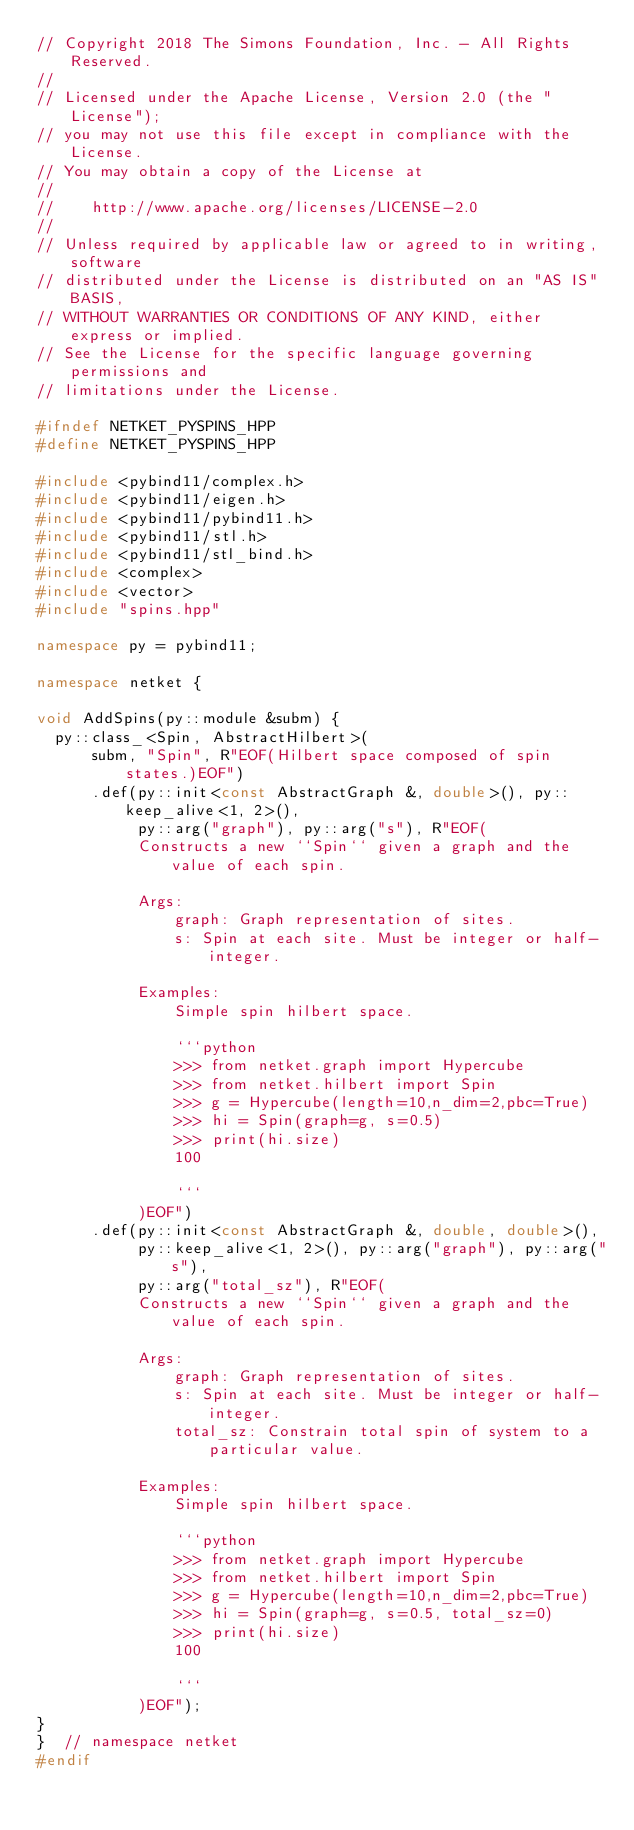<code> <loc_0><loc_0><loc_500><loc_500><_C++_>// Copyright 2018 The Simons Foundation, Inc. - All Rights Reserved.
//
// Licensed under the Apache License, Version 2.0 (the "License");
// you may not use this file except in compliance with the License.
// You may obtain a copy of the License at
//
//    http://www.apache.org/licenses/LICENSE-2.0
//
// Unless required by applicable law or agreed to in writing, software
// distributed under the License is distributed on an "AS IS" BASIS,
// WITHOUT WARRANTIES OR CONDITIONS OF ANY KIND, either express or implied.
// See the License for the specific language governing permissions and
// limitations under the License.

#ifndef NETKET_PYSPINS_HPP
#define NETKET_PYSPINS_HPP

#include <pybind11/complex.h>
#include <pybind11/eigen.h>
#include <pybind11/pybind11.h>
#include <pybind11/stl.h>
#include <pybind11/stl_bind.h>
#include <complex>
#include <vector>
#include "spins.hpp"

namespace py = pybind11;

namespace netket {

void AddSpins(py::module &subm) {
  py::class_<Spin, AbstractHilbert>(
      subm, "Spin", R"EOF(Hilbert space composed of spin states.)EOF")
      .def(py::init<const AbstractGraph &, double>(), py::keep_alive<1, 2>(),
           py::arg("graph"), py::arg("s"), R"EOF(
           Constructs a new ``Spin`` given a graph and the value of each spin.

           Args:
               graph: Graph representation of sites.
               s: Spin at each site. Must be integer or half-integer.

           Examples:
               Simple spin hilbert space.

               ```python
               >>> from netket.graph import Hypercube
               >>> from netket.hilbert import Spin
               >>> g = Hypercube(length=10,n_dim=2,pbc=True)
               >>> hi = Spin(graph=g, s=0.5)
               >>> print(hi.size)
               100

               ```
           )EOF")
      .def(py::init<const AbstractGraph &, double, double>(),
           py::keep_alive<1, 2>(), py::arg("graph"), py::arg("s"),
           py::arg("total_sz"), R"EOF(
           Constructs a new ``Spin`` given a graph and the value of each spin.

           Args:
               graph: Graph representation of sites.
               s: Spin at each site. Must be integer or half-integer.
               total_sz: Constrain total spin of system to a particular value.

           Examples:
               Simple spin hilbert space.

               ```python
               >>> from netket.graph import Hypercube
               >>> from netket.hilbert import Spin
               >>> g = Hypercube(length=10,n_dim=2,pbc=True)
               >>> hi = Spin(graph=g, s=0.5, total_sz=0)
               >>> print(hi.size)
               100

               ```
           )EOF");
}
}  // namespace netket
#endif
</code> 